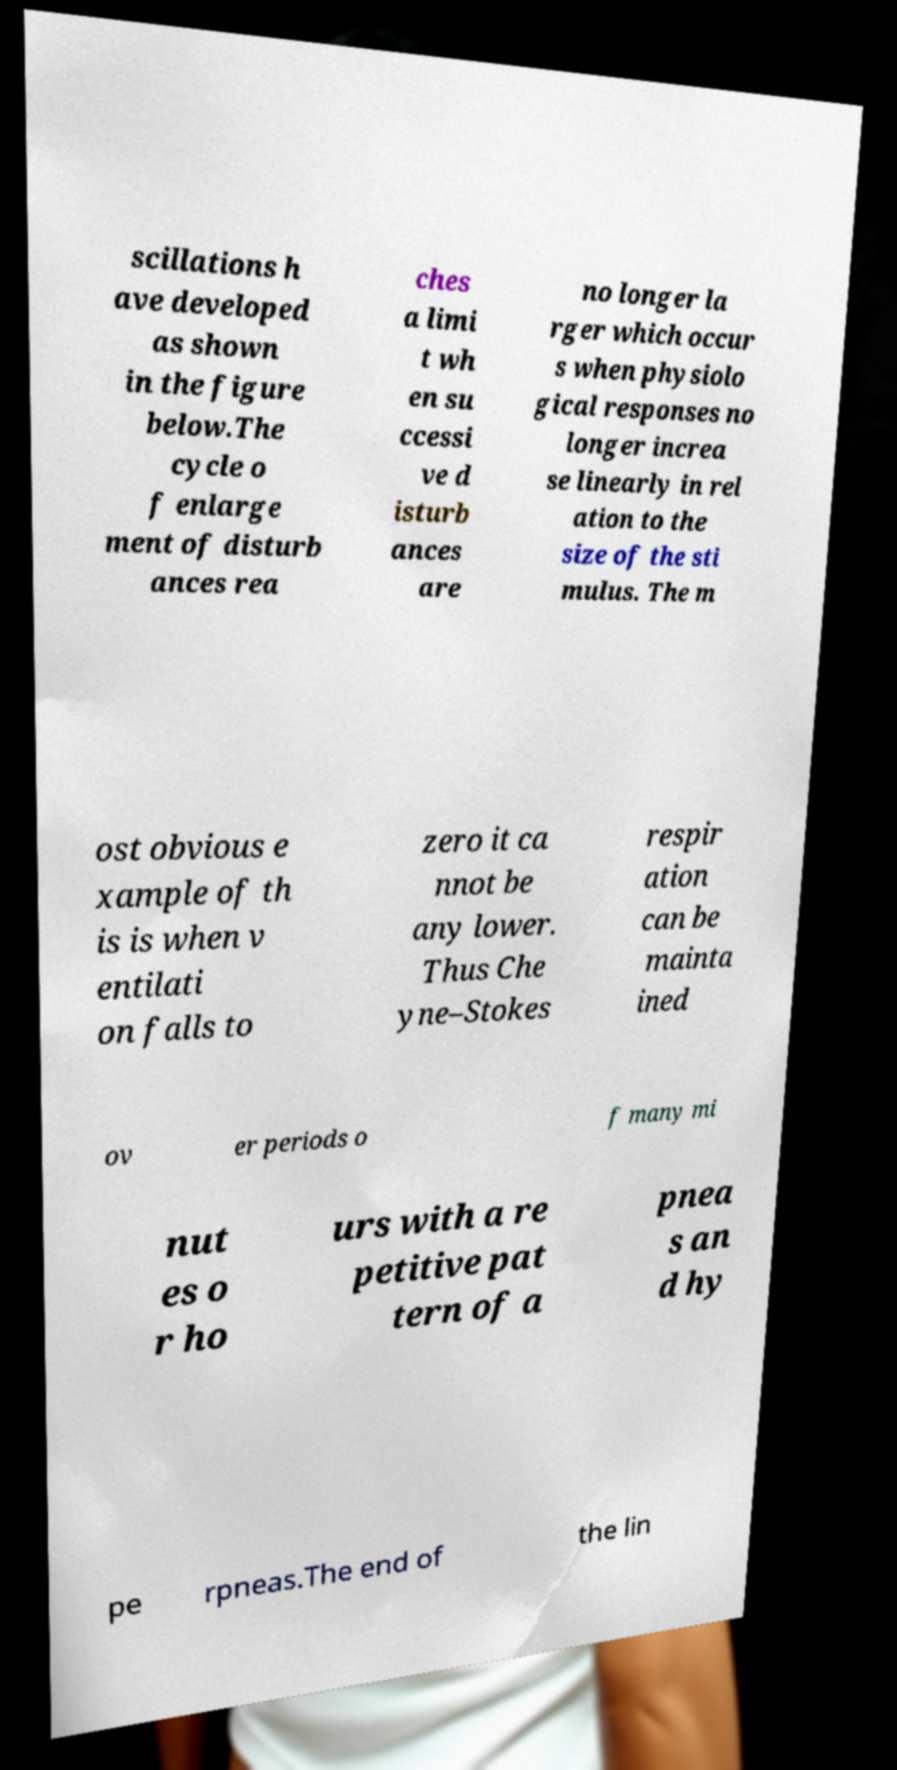Please identify and transcribe the text found in this image. scillations h ave developed as shown in the figure below.The cycle o f enlarge ment of disturb ances rea ches a limi t wh en su ccessi ve d isturb ances are no longer la rger which occur s when physiolo gical responses no longer increa se linearly in rel ation to the size of the sti mulus. The m ost obvious e xample of th is is when v entilati on falls to zero it ca nnot be any lower. Thus Che yne–Stokes respir ation can be mainta ined ov er periods o f many mi nut es o r ho urs with a re petitive pat tern of a pnea s an d hy pe rpneas.The end of the lin 